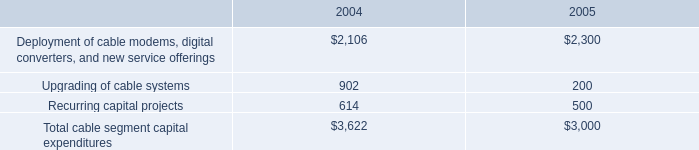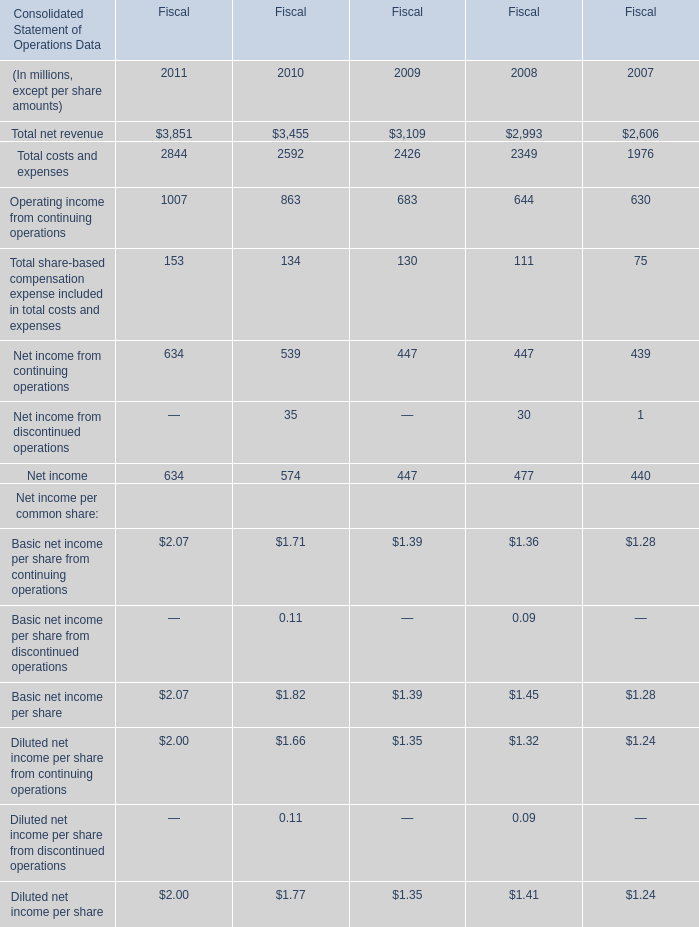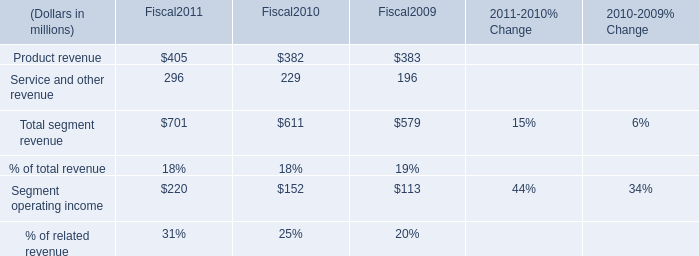what was the approximate sum of the addition to our intangibles in 2004 in millions 
Computations: (168 + (250 + 133))
Answer: 551.0. 